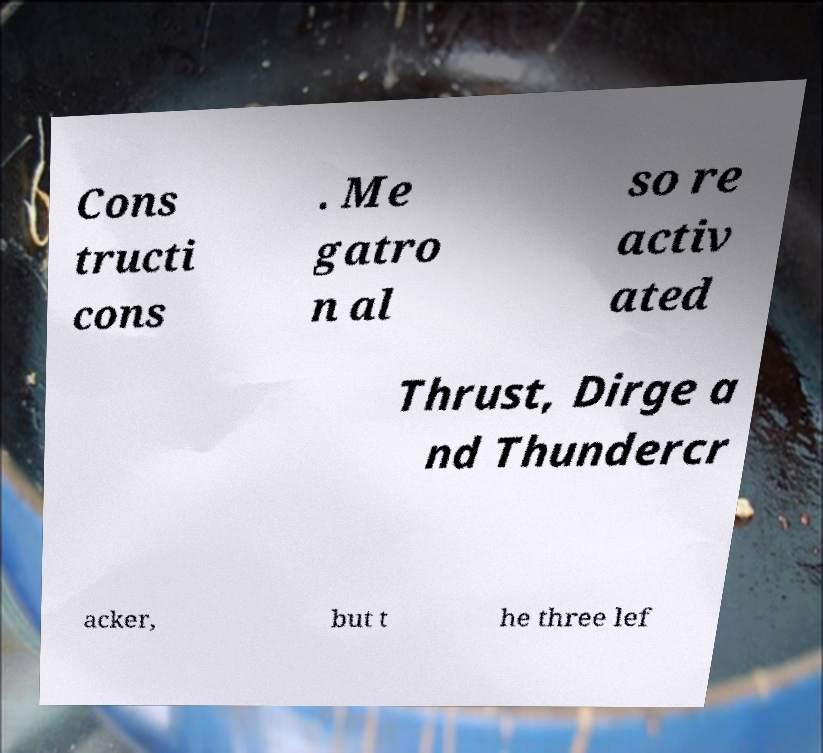For documentation purposes, I need the text within this image transcribed. Could you provide that? Cons tructi cons . Me gatro n al so re activ ated Thrust, Dirge a nd Thundercr acker, but t he three lef 